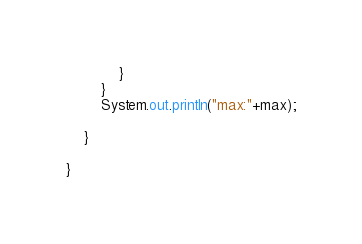<code> <loc_0><loc_0><loc_500><loc_500><_Java_>			}
		}
		System.out.println("max:"+max);
		
	}

}
</code> 